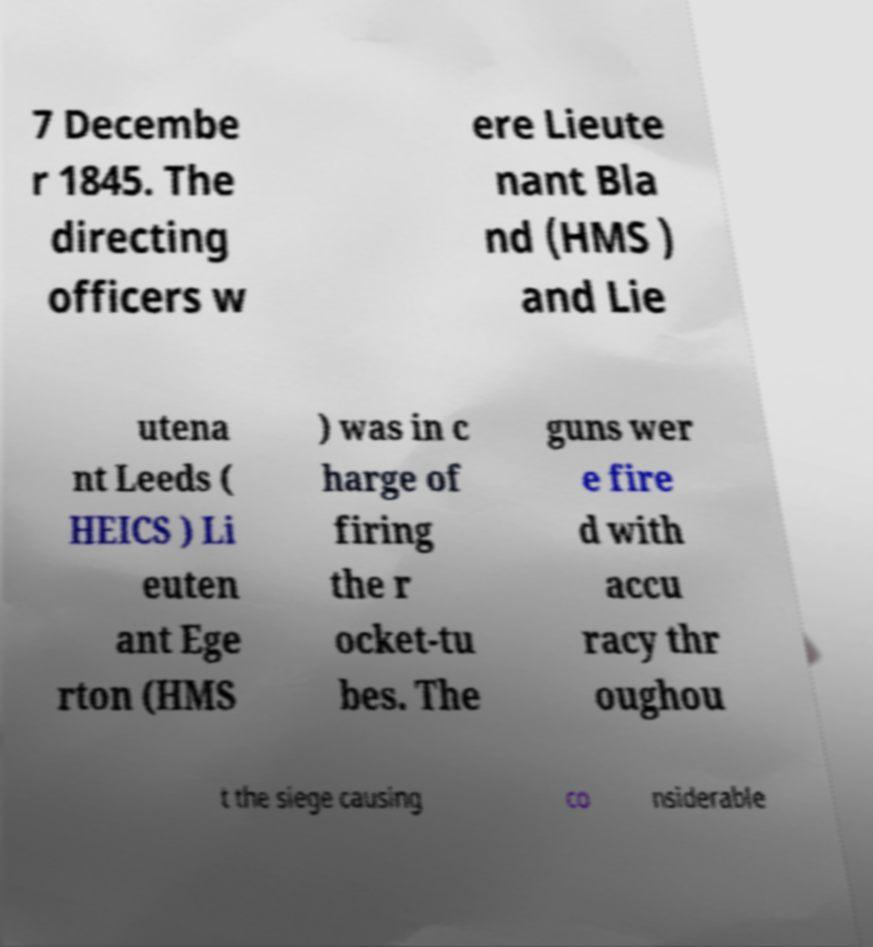For documentation purposes, I need the text within this image transcribed. Could you provide that? 7 Decembe r 1845. The directing officers w ere Lieute nant Bla nd (HMS ) and Lie utena nt Leeds ( HEICS ) Li euten ant Ege rton (HMS ) was in c harge of firing the r ocket-tu bes. The guns wer e fire d with accu racy thr oughou t the siege causing co nsiderable 